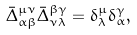Convert formula to latex. <formula><loc_0><loc_0><loc_500><loc_500>\bar { \Delta } ^ { \mu \nu } _ { \alpha \beta } \bar { \Delta } _ { \nu \lambda } ^ { \beta \gamma } = \delta ^ { \mu } _ { \lambda } \delta _ { \alpha } ^ { \gamma } ,</formula> 